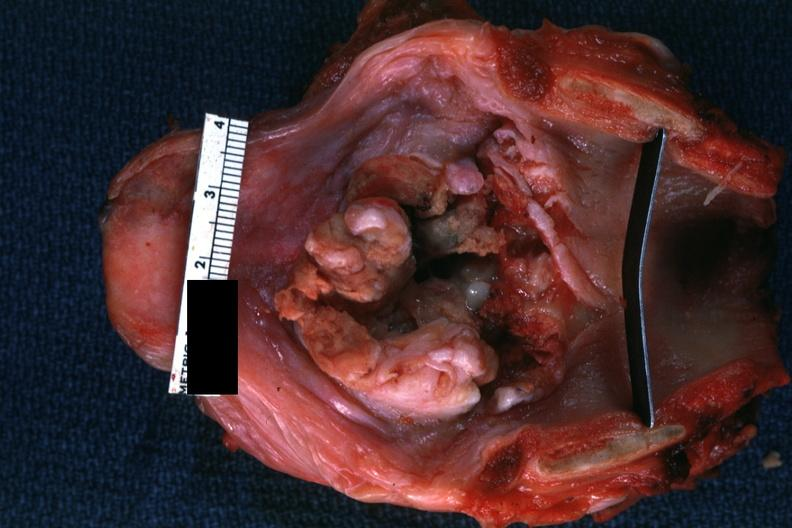what does this image show?
Answer the question using a single word or phrase. Large lesion good but not the best 